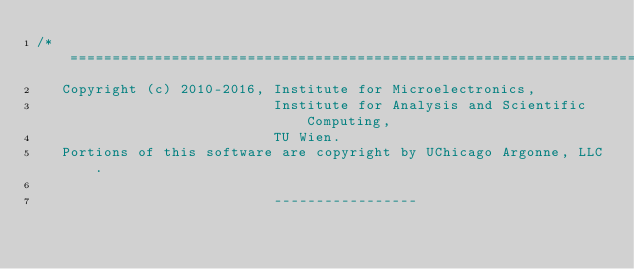<code> <loc_0><loc_0><loc_500><loc_500><_Cuda_>/* =========================================================================
   Copyright (c) 2010-2016, Institute for Microelectronics,
                            Institute for Analysis and Scientific Computing,
                            TU Wien.
   Portions of this software are copyright by UChicago Argonne, LLC.

                            -----------------</code> 